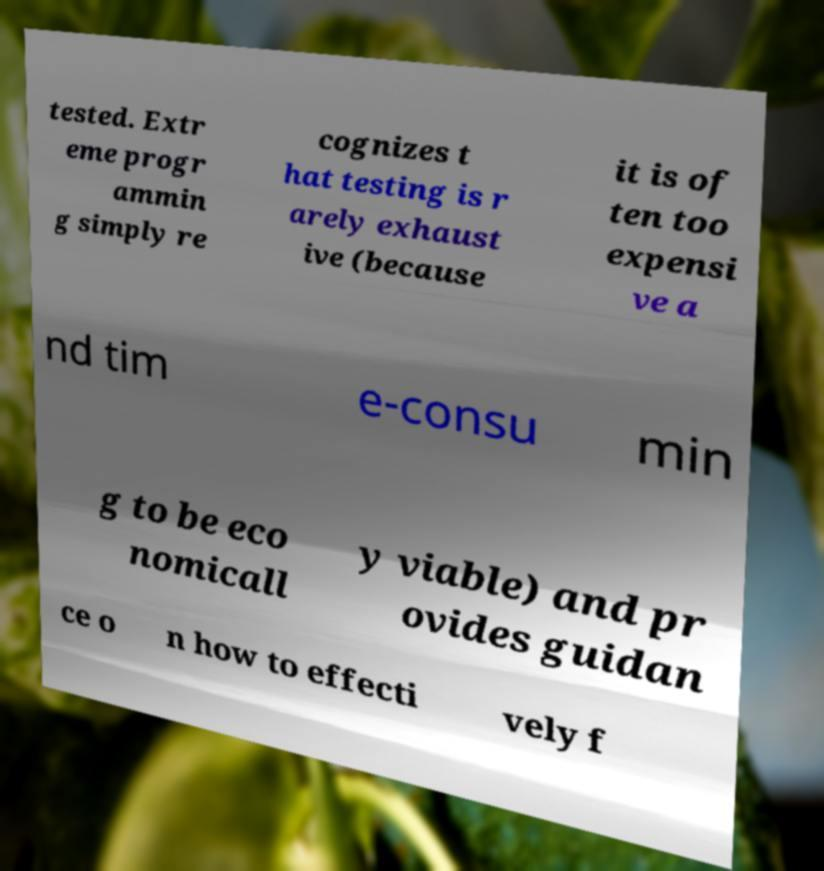I need the written content from this picture converted into text. Can you do that? tested. Extr eme progr ammin g simply re cognizes t hat testing is r arely exhaust ive (because it is of ten too expensi ve a nd tim e-consu min g to be eco nomicall y viable) and pr ovides guidan ce o n how to effecti vely f 